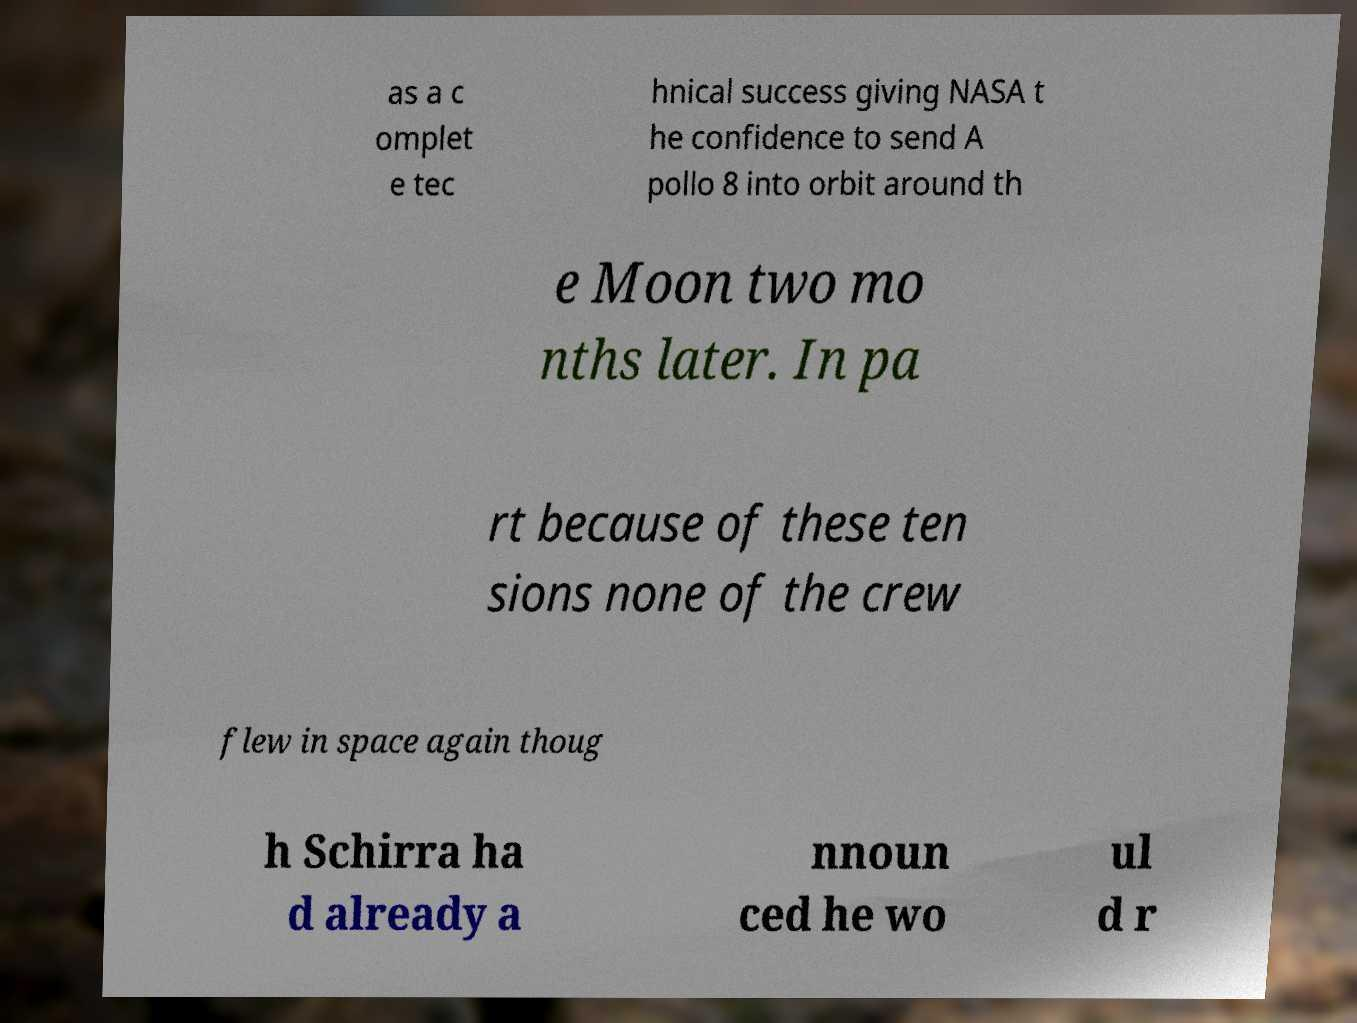For documentation purposes, I need the text within this image transcribed. Could you provide that? as a c omplet e tec hnical success giving NASA t he confidence to send A pollo 8 into orbit around th e Moon two mo nths later. In pa rt because of these ten sions none of the crew flew in space again thoug h Schirra ha d already a nnoun ced he wo ul d r 